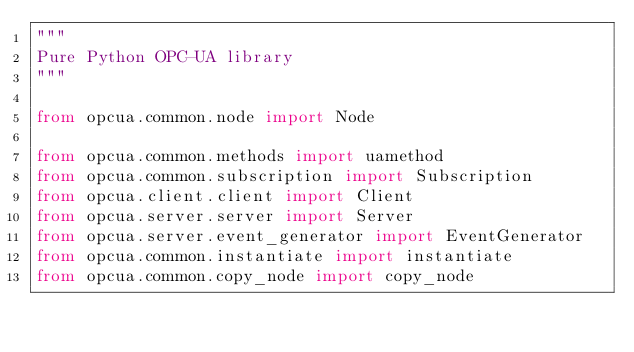Convert code to text. <code><loc_0><loc_0><loc_500><loc_500><_Python_>"""
Pure Python OPC-UA library
"""

from opcua.common.node import Node

from opcua.common.methods import uamethod
from opcua.common.subscription import Subscription
from opcua.client.client import Client
from opcua.server.server import Server
from opcua.server.event_generator import EventGenerator
from opcua.common.instantiate import instantiate
from opcua.common.copy_node import copy_node



</code> 